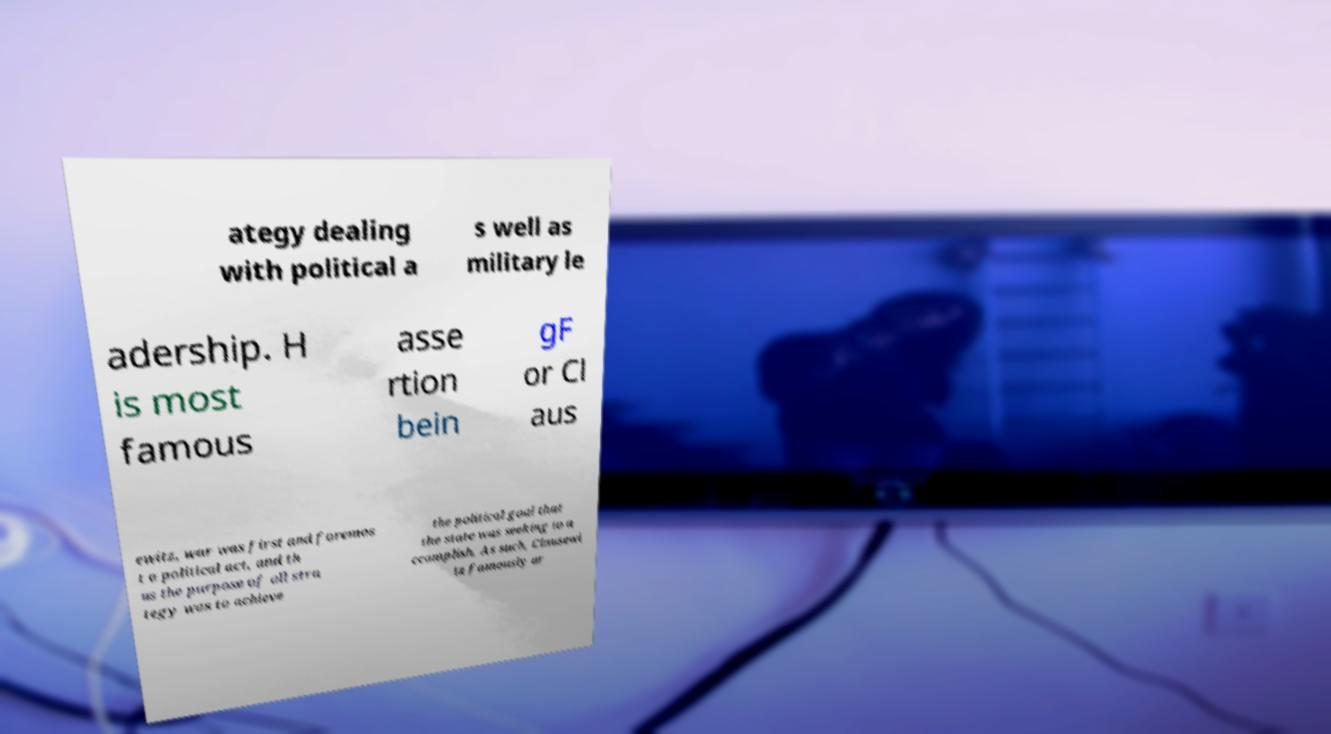Can you read and provide the text displayed in the image?This photo seems to have some interesting text. Can you extract and type it out for me? ategy dealing with political a s well as military le adership. H is most famous asse rtion bein gF or Cl aus ewitz, war was first and foremos t a political act, and th us the purpose of all stra tegy was to achieve the political goal that the state was seeking to a ccomplish. As such, Clausewi tz famously ar 